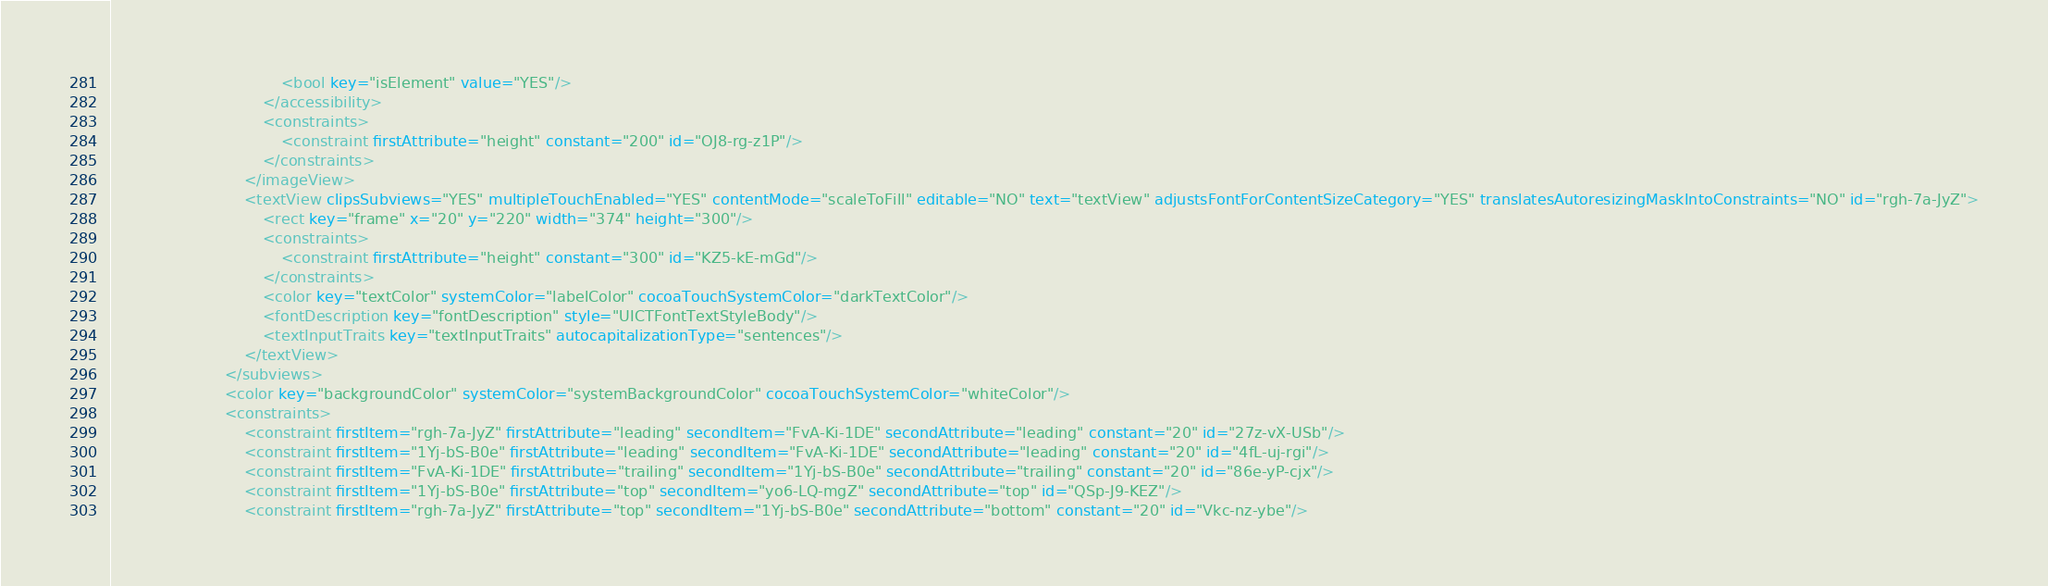Convert code to text. <code><loc_0><loc_0><loc_500><loc_500><_XML_>                                    <bool key="isElement" value="YES"/>
                                </accessibility>
                                <constraints>
                                    <constraint firstAttribute="height" constant="200" id="OJ8-rg-z1P"/>
                                </constraints>
                            </imageView>
                            <textView clipsSubviews="YES" multipleTouchEnabled="YES" contentMode="scaleToFill" editable="NO" text="textView" adjustsFontForContentSizeCategory="YES" translatesAutoresizingMaskIntoConstraints="NO" id="rgh-7a-JyZ">
                                <rect key="frame" x="20" y="220" width="374" height="300"/>
                                <constraints>
                                    <constraint firstAttribute="height" constant="300" id="KZ5-kE-mGd"/>
                                </constraints>
                                <color key="textColor" systemColor="labelColor" cocoaTouchSystemColor="darkTextColor"/>
                                <fontDescription key="fontDescription" style="UICTFontTextStyleBody"/>
                                <textInputTraits key="textInputTraits" autocapitalizationType="sentences"/>
                            </textView>
                        </subviews>
                        <color key="backgroundColor" systemColor="systemBackgroundColor" cocoaTouchSystemColor="whiteColor"/>
                        <constraints>
                            <constraint firstItem="rgh-7a-JyZ" firstAttribute="leading" secondItem="FvA-Ki-1DE" secondAttribute="leading" constant="20" id="27z-vX-USb"/>
                            <constraint firstItem="1Yj-bS-B0e" firstAttribute="leading" secondItem="FvA-Ki-1DE" secondAttribute="leading" constant="20" id="4fL-uj-rgi"/>
                            <constraint firstItem="FvA-Ki-1DE" firstAttribute="trailing" secondItem="1Yj-bS-B0e" secondAttribute="trailing" constant="20" id="86e-yP-cjx"/>
                            <constraint firstItem="1Yj-bS-B0e" firstAttribute="top" secondItem="yo6-LQ-mgZ" secondAttribute="top" id="QSp-J9-KEZ"/>
                            <constraint firstItem="rgh-7a-JyZ" firstAttribute="top" secondItem="1Yj-bS-B0e" secondAttribute="bottom" constant="20" id="Vkc-nz-ybe"/></code> 